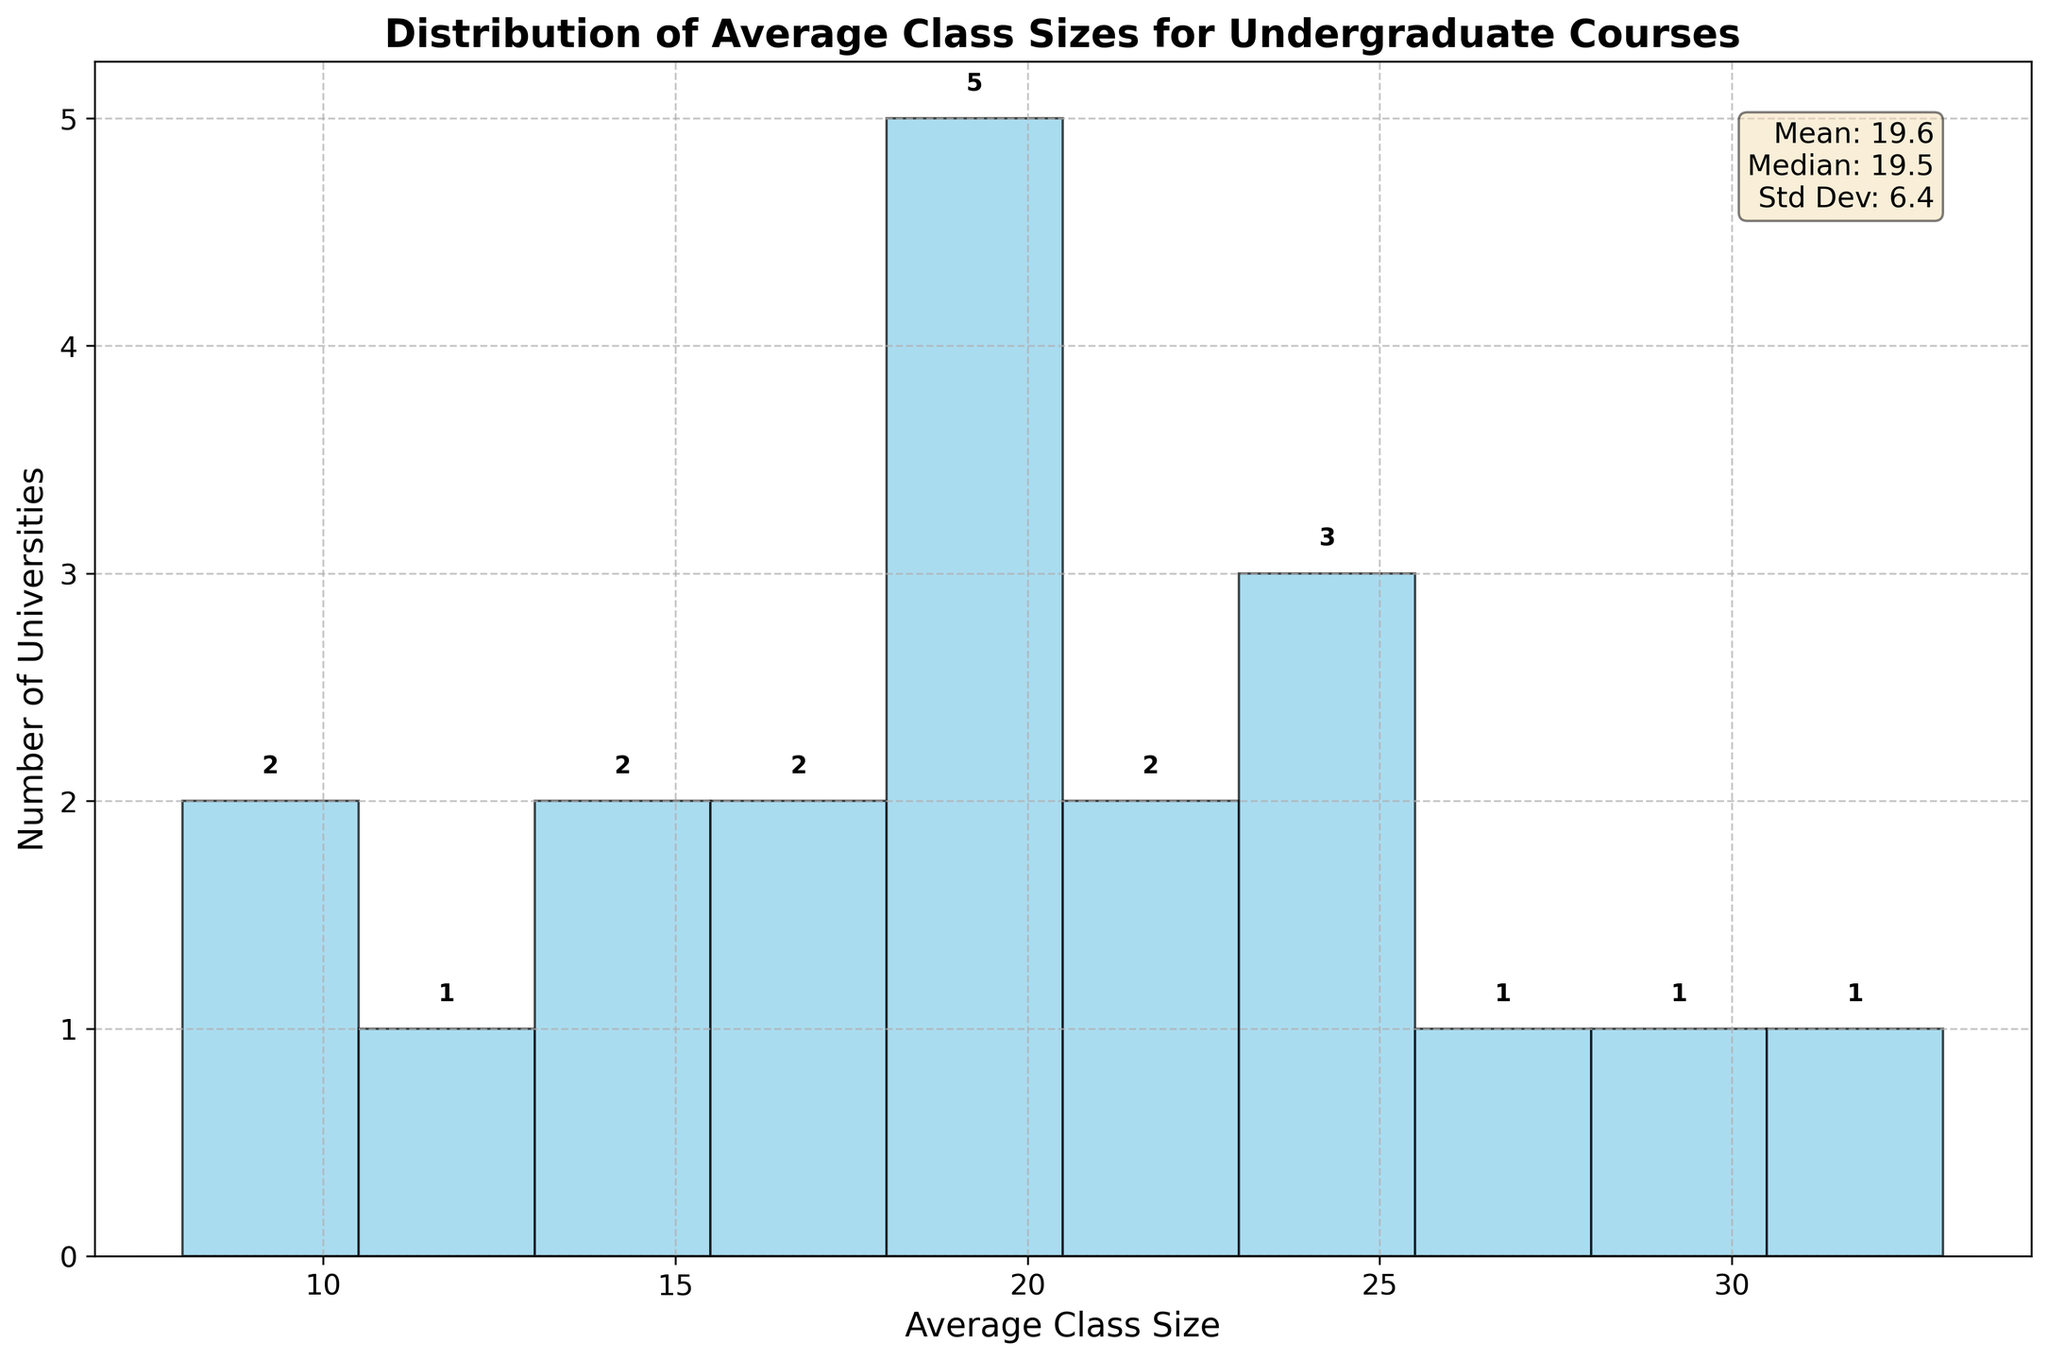What is the title of the figure? The title of the figure is written at the top and indicates the main focus or topic of the chart.
Answer: Distribution of Average Class Sizes for Undergraduate Courses How many universities have an average class size between 15 and 20? This range corresponds to a specific bin on the x-axis, and we can check the bar height in this range to determine the count.
Answer: 7 What is the mean of the average class sizes? The mean is provided in the statistics text box at the top right corner of the plot.
Answer: 19.6 Which university has the smallest average class size and what is it? The plot does not directly mention names, but typically the extremes can be cross-checked with original data provided before plotting.
Answer: Caltech, 8 What is the median of the average class sizes? The median value is provided in the text box containing plot statistics.
Answer: 19.0 Are there more universities with average class sizes below 20 or above 20? To find this, we need to count the bins below 20 and those above 20. Sum the frequencies of the bars accordingly.
Answer: Below 20 What's the range of class sizes with the highest frequency? To determine this, look for the tallest bar on the histogram and check its range on the x-axis.
Answer: 15 to 20 How many bins are in the histogram? Bins are the intervals on the x-axis used to group the data. Count the number of these intervals in the plot.
Answer: 10 Which university lies exactly on the mean of the average class sizes? The mean (19.6) must be compared to the university data provided before plotting. However, the exact match might not be present, one needs to see the nearest value.
Answer: No university exactly; closest value is 20 (Cornell University, Vanderbilt University) What is the standard deviation of the average class sizes? The standard deviation is detailed in the text box with the statistics on the top right corner of the plot.
Answer: 7.2 